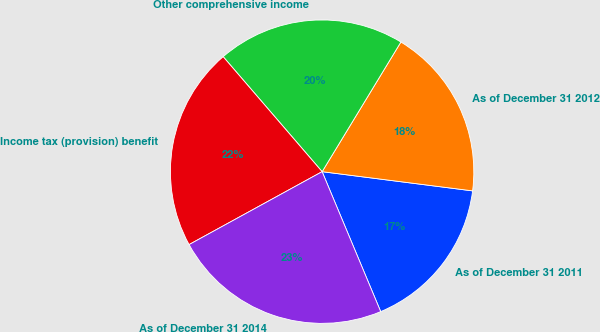Convert chart to OTSL. <chart><loc_0><loc_0><loc_500><loc_500><pie_chart><fcel>As of December 31 2011<fcel>As of December 31 2012<fcel>Other comprehensive income<fcel>Income tax (provision) benefit<fcel>As of December 31 2014<nl><fcel>16.67%<fcel>18.33%<fcel>20.0%<fcel>21.67%<fcel>23.33%<nl></chart> 